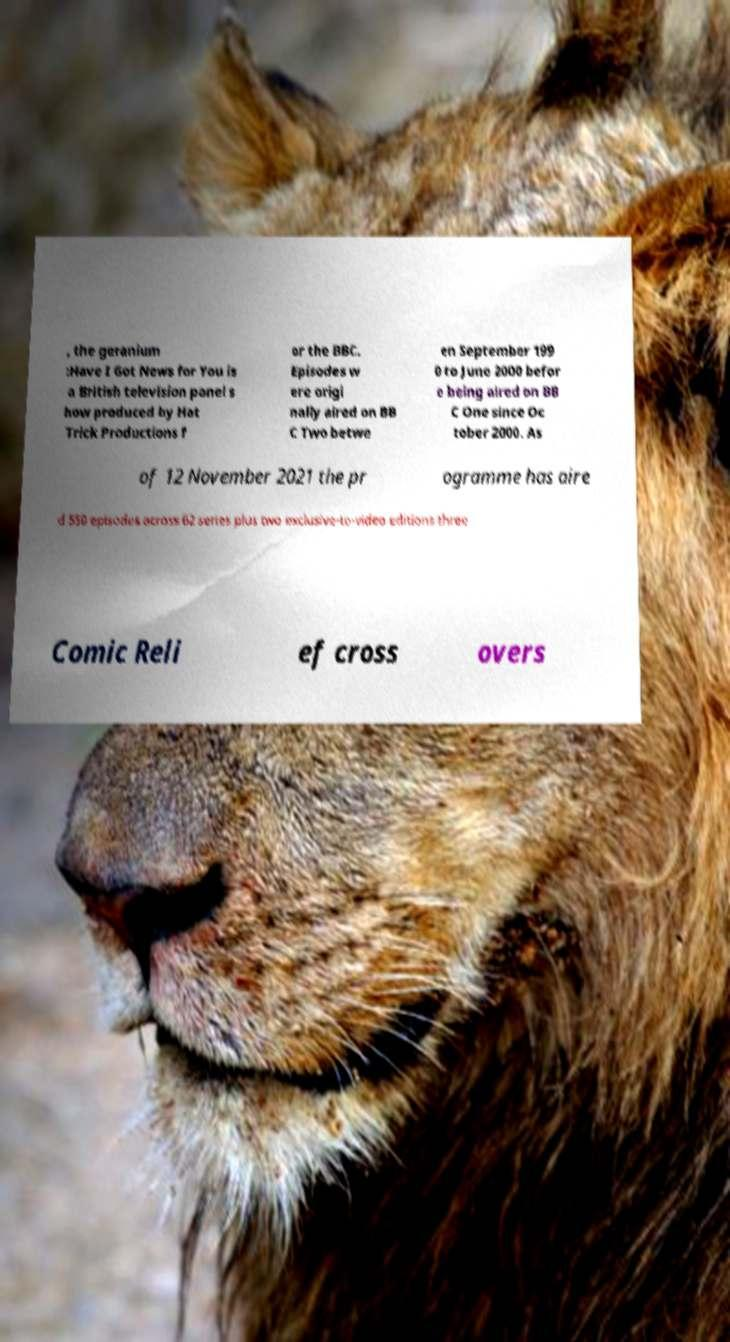For documentation purposes, I need the text within this image transcribed. Could you provide that? , the geranium :Have I Got News for You is a British television panel s how produced by Hat Trick Productions f or the BBC. Episodes w ere origi nally aired on BB C Two betwe en September 199 0 to June 2000 befor e being aired on BB C One since Oc tober 2000. As of 12 November 2021 the pr ogramme has aire d 550 episodes across 62 series plus two exclusive-to-video editions three Comic Reli ef cross overs 